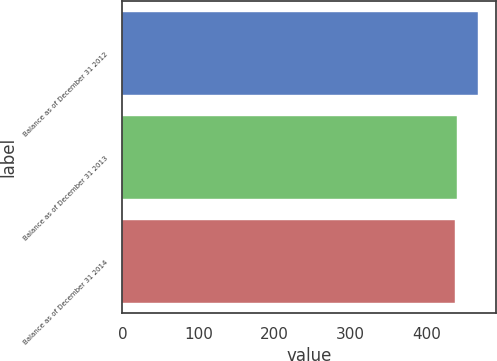Convert chart. <chart><loc_0><loc_0><loc_500><loc_500><bar_chart><fcel>Balance as of December 31 2012<fcel>Balance as of December 31 2013<fcel>Balance as of December 31 2014<nl><fcel>468<fcel>440.1<fcel>437<nl></chart> 